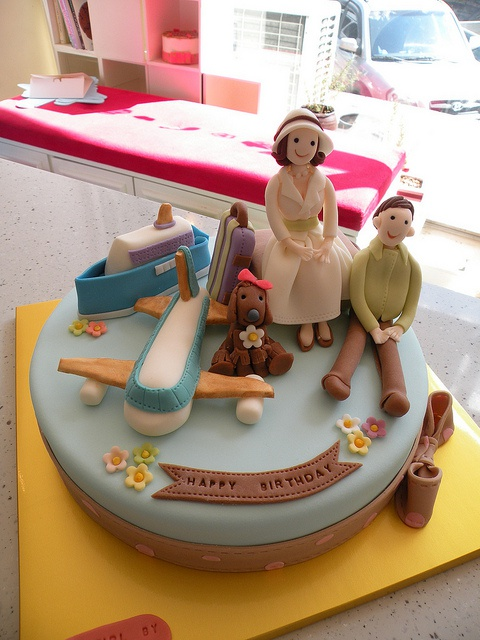Describe the objects in this image and their specific colors. I can see cake in tan, darkgray, and gray tones, airplane in tan, gray, and brown tones, car in tan, white, lightblue, and darkgray tones, boat in tan, blue, gray, and darkgray tones, and dog in tan, maroon, black, and gray tones in this image. 